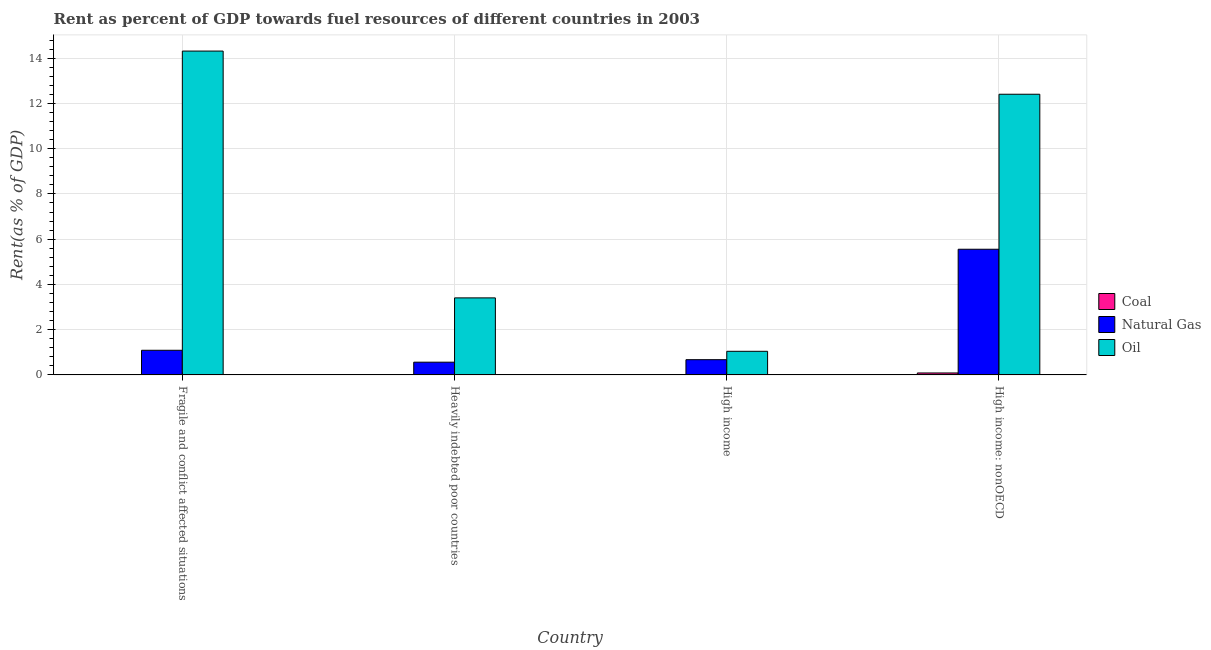How many different coloured bars are there?
Make the answer very short. 3. How many bars are there on the 2nd tick from the left?
Make the answer very short. 3. How many bars are there on the 4th tick from the right?
Make the answer very short. 3. What is the label of the 1st group of bars from the left?
Give a very brief answer. Fragile and conflict affected situations. In how many cases, is the number of bars for a given country not equal to the number of legend labels?
Provide a succinct answer. 0. What is the rent towards coal in Heavily indebted poor countries?
Give a very brief answer. 0. Across all countries, what is the maximum rent towards natural gas?
Provide a succinct answer. 5.55. Across all countries, what is the minimum rent towards oil?
Make the answer very short. 1.04. In which country was the rent towards oil maximum?
Your answer should be very brief. Fragile and conflict affected situations. In which country was the rent towards coal minimum?
Keep it short and to the point. Heavily indebted poor countries. What is the total rent towards natural gas in the graph?
Ensure brevity in your answer.  7.88. What is the difference between the rent towards natural gas in Fragile and conflict affected situations and that in High income: nonOECD?
Keep it short and to the point. -4.47. What is the difference between the rent towards natural gas in Heavily indebted poor countries and the rent towards oil in High income: nonOECD?
Offer a terse response. -11.84. What is the average rent towards coal per country?
Provide a succinct answer. 0.02. What is the difference between the rent towards natural gas and rent towards coal in High income?
Your response must be concise. 0.67. In how many countries, is the rent towards oil greater than 5.2 %?
Provide a short and direct response. 2. What is the ratio of the rent towards oil in Heavily indebted poor countries to that in High income: nonOECD?
Keep it short and to the point. 0.27. Is the rent towards natural gas in Fragile and conflict affected situations less than that in Heavily indebted poor countries?
Your answer should be very brief. No. What is the difference between the highest and the second highest rent towards natural gas?
Your answer should be compact. 4.47. What is the difference between the highest and the lowest rent towards oil?
Give a very brief answer. 13.27. What does the 3rd bar from the left in High income: nonOECD represents?
Ensure brevity in your answer.  Oil. What does the 2nd bar from the right in Heavily indebted poor countries represents?
Make the answer very short. Natural Gas. Is it the case that in every country, the sum of the rent towards coal and rent towards natural gas is greater than the rent towards oil?
Offer a terse response. No. How many bars are there?
Give a very brief answer. 12. Are all the bars in the graph horizontal?
Your answer should be very brief. No. How many countries are there in the graph?
Your answer should be compact. 4. Are the values on the major ticks of Y-axis written in scientific E-notation?
Ensure brevity in your answer.  No. Does the graph contain any zero values?
Your answer should be very brief. No. How many legend labels are there?
Your response must be concise. 3. How are the legend labels stacked?
Provide a succinct answer. Vertical. What is the title of the graph?
Give a very brief answer. Rent as percent of GDP towards fuel resources of different countries in 2003. Does "Industry" appear as one of the legend labels in the graph?
Give a very brief answer. No. What is the label or title of the Y-axis?
Your answer should be very brief. Rent(as % of GDP). What is the Rent(as % of GDP) in Coal in Fragile and conflict affected situations?
Your response must be concise. 0. What is the Rent(as % of GDP) in Natural Gas in Fragile and conflict affected situations?
Make the answer very short. 1.09. What is the Rent(as % of GDP) in Oil in Fragile and conflict affected situations?
Your response must be concise. 14.31. What is the Rent(as % of GDP) in Coal in Heavily indebted poor countries?
Your answer should be compact. 0. What is the Rent(as % of GDP) of Natural Gas in Heavily indebted poor countries?
Your response must be concise. 0.56. What is the Rent(as % of GDP) in Oil in Heavily indebted poor countries?
Your answer should be very brief. 3.4. What is the Rent(as % of GDP) of Coal in High income?
Ensure brevity in your answer.  0.01. What is the Rent(as % of GDP) in Natural Gas in High income?
Offer a terse response. 0.67. What is the Rent(as % of GDP) of Oil in High income?
Ensure brevity in your answer.  1.04. What is the Rent(as % of GDP) in Coal in High income: nonOECD?
Your answer should be very brief. 0.09. What is the Rent(as % of GDP) of Natural Gas in High income: nonOECD?
Provide a succinct answer. 5.55. What is the Rent(as % of GDP) of Oil in High income: nonOECD?
Make the answer very short. 12.4. Across all countries, what is the maximum Rent(as % of GDP) in Coal?
Your answer should be very brief. 0.09. Across all countries, what is the maximum Rent(as % of GDP) in Natural Gas?
Keep it short and to the point. 5.55. Across all countries, what is the maximum Rent(as % of GDP) of Oil?
Provide a short and direct response. 14.31. Across all countries, what is the minimum Rent(as % of GDP) of Coal?
Keep it short and to the point. 0. Across all countries, what is the minimum Rent(as % of GDP) in Natural Gas?
Your answer should be compact. 0.56. Across all countries, what is the minimum Rent(as % of GDP) in Oil?
Offer a very short reply. 1.04. What is the total Rent(as % of GDP) of Coal in the graph?
Keep it short and to the point. 0.09. What is the total Rent(as % of GDP) in Natural Gas in the graph?
Offer a very short reply. 7.88. What is the total Rent(as % of GDP) in Oil in the graph?
Provide a short and direct response. 31.17. What is the difference between the Rent(as % of GDP) in Natural Gas in Fragile and conflict affected situations and that in Heavily indebted poor countries?
Your answer should be very brief. 0.53. What is the difference between the Rent(as % of GDP) of Oil in Fragile and conflict affected situations and that in Heavily indebted poor countries?
Ensure brevity in your answer.  10.91. What is the difference between the Rent(as % of GDP) of Coal in Fragile and conflict affected situations and that in High income?
Keep it short and to the point. -0.01. What is the difference between the Rent(as % of GDP) of Natural Gas in Fragile and conflict affected situations and that in High income?
Your answer should be very brief. 0.42. What is the difference between the Rent(as % of GDP) of Oil in Fragile and conflict affected situations and that in High income?
Your answer should be very brief. 13.27. What is the difference between the Rent(as % of GDP) in Coal in Fragile and conflict affected situations and that in High income: nonOECD?
Provide a short and direct response. -0.09. What is the difference between the Rent(as % of GDP) of Natural Gas in Fragile and conflict affected situations and that in High income: nonOECD?
Give a very brief answer. -4.47. What is the difference between the Rent(as % of GDP) in Oil in Fragile and conflict affected situations and that in High income: nonOECD?
Offer a very short reply. 1.91. What is the difference between the Rent(as % of GDP) in Coal in Heavily indebted poor countries and that in High income?
Provide a short and direct response. -0.01. What is the difference between the Rent(as % of GDP) of Natural Gas in Heavily indebted poor countries and that in High income?
Your response must be concise. -0.11. What is the difference between the Rent(as % of GDP) in Oil in Heavily indebted poor countries and that in High income?
Offer a terse response. 2.36. What is the difference between the Rent(as % of GDP) in Coal in Heavily indebted poor countries and that in High income: nonOECD?
Keep it short and to the point. -0.09. What is the difference between the Rent(as % of GDP) in Natural Gas in Heavily indebted poor countries and that in High income: nonOECD?
Offer a very short reply. -4.99. What is the difference between the Rent(as % of GDP) of Oil in Heavily indebted poor countries and that in High income: nonOECD?
Your answer should be compact. -9. What is the difference between the Rent(as % of GDP) of Coal in High income and that in High income: nonOECD?
Your response must be concise. -0.08. What is the difference between the Rent(as % of GDP) in Natural Gas in High income and that in High income: nonOECD?
Give a very brief answer. -4.88. What is the difference between the Rent(as % of GDP) in Oil in High income and that in High income: nonOECD?
Offer a terse response. -11.36. What is the difference between the Rent(as % of GDP) of Coal in Fragile and conflict affected situations and the Rent(as % of GDP) of Natural Gas in Heavily indebted poor countries?
Provide a short and direct response. -0.56. What is the difference between the Rent(as % of GDP) in Coal in Fragile and conflict affected situations and the Rent(as % of GDP) in Oil in Heavily indebted poor countries?
Ensure brevity in your answer.  -3.4. What is the difference between the Rent(as % of GDP) in Natural Gas in Fragile and conflict affected situations and the Rent(as % of GDP) in Oil in Heavily indebted poor countries?
Make the answer very short. -2.32. What is the difference between the Rent(as % of GDP) in Coal in Fragile and conflict affected situations and the Rent(as % of GDP) in Natural Gas in High income?
Your answer should be compact. -0.67. What is the difference between the Rent(as % of GDP) of Coal in Fragile and conflict affected situations and the Rent(as % of GDP) of Oil in High income?
Make the answer very short. -1.04. What is the difference between the Rent(as % of GDP) of Natural Gas in Fragile and conflict affected situations and the Rent(as % of GDP) of Oil in High income?
Provide a succinct answer. 0.05. What is the difference between the Rent(as % of GDP) in Coal in Fragile and conflict affected situations and the Rent(as % of GDP) in Natural Gas in High income: nonOECD?
Provide a succinct answer. -5.55. What is the difference between the Rent(as % of GDP) of Coal in Fragile and conflict affected situations and the Rent(as % of GDP) of Oil in High income: nonOECD?
Provide a succinct answer. -12.4. What is the difference between the Rent(as % of GDP) in Natural Gas in Fragile and conflict affected situations and the Rent(as % of GDP) in Oil in High income: nonOECD?
Offer a terse response. -11.32. What is the difference between the Rent(as % of GDP) of Coal in Heavily indebted poor countries and the Rent(as % of GDP) of Natural Gas in High income?
Offer a terse response. -0.67. What is the difference between the Rent(as % of GDP) in Coal in Heavily indebted poor countries and the Rent(as % of GDP) in Oil in High income?
Provide a short and direct response. -1.04. What is the difference between the Rent(as % of GDP) of Natural Gas in Heavily indebted poor countries and the Rent(as % of GDP) of Oil in High income?
Keep it short and to the point. -0.48. What is the difference between the Rent(as % of GDP) in Coal in Heavily indebted poor countries and the Rent(as % of GDP) in Natural Gas in High income: nonOECD?
Give a very brief answer. -5.55. What is the difference between the Rent(as % of GDP) of Coal in Heavily indebted poor countries and the Rent(as % of GDP) of Oil in High income: nonOECD?
Ensure brevity in your answer.  -12.4. What is the difference between the Rent(as % of GDP) in Natural Gas in Heavily indebted poor countries and the Rent(as % of GDP) in Oil in High income: nonOECD?
Give a very brief answer. -11.84. What is the difference between the Rent(as % of GDP) in Coal in High income and the Rent(as % of GDP) in Natural Gas in High income: nonOECD?
Provide a short and direct response. -5.55. What is the difference between the Rent(as % of GDP) of Coal in High income and the Rent(as % of GDP) of Oil in High income: nonOECD?
Offer a very short reply. -12.4. What is the difference between the Rent(as % of GDP) in Natural Gas in High income and the Rent(as % of GDP) in Oil in High income: nonOECD?
Provide a short and direct response. -11.73. What is the average Rent(as % of GDP) of Coal per country?
Your response must be concise. 0.02. What is the average Rent(as % of GDP) of Natural Gas per country?
Give a very brief answer. 1.97. What is the average Rent(as % of GDP) of Oil per country?
Keep it short and to the point. 7.79. What is the difference between the Rent(as % of GDP) in Coal and Rent(as % of GDP) in Natural Gas in Fragile and conflict affected situations?
Offer a terse response. -1.09. What is the difference between the Rent(as % of GDP) of Coal and Rent(as % of GDP) of Oil in Fragile and conflict affected situations?
Offer a terse response. -14.31. What is the difference between the Rent(as % of GDP) of Natural Gas and Rent(as % of GDP) of Oil in Fragile and conflict affected situations?
Offer a terse response. -13.22. What is the difference between the Rent(as % of GDP) in Coal and Rent(as % of GDP) in Natural Gas in Heavily indebted poor countries?
Offer a terse response. -0.56. What is the difference between the Rent(as % of GDP) in Coal and Rent(as % of GDP) in Oil in Heavily indebted poor countries?
Your answer should be very brief. -3.4. What is the difference between the Rent(as % of GDP) in Natural Gas and Rent(as % of GDP) in Oil in Heavily indebted poor countries?
Give a very brief answer. -2.84. What is the difference between the Rent(as % of GDP) in Coal and Rent(as % of GDP) in Natural Gas in High income?
Your answer should be compact. -0.67. What is the difference between the Rent(as % of GDP) of Coal and Rent(as % of GDP) of Oil in High income?
Your response must be concise. -1.04. What is the difference between the Rent(as % of GDP) in Natural Gas and Rent(as % of GDP) in Oil in High income?
Offer a terse response. -0.37. What is the difference between the Rent(as % of GDP) in Coal and Rent(as % of GDP) in Natural Gas in High income: nonOECD?
Provide a short and direct response. -5.47. What is the difference between the Rent(as % of GDP) in Coal and Rent(as % of GDP) in Oil in High income: nonOECD?
Keep it short and to the point. -12.32. What is the difference between the Rent(as % of GDP) of Natural Gas and Rent(as % of GDP) of Oil in High income: nonOECD?
Offer a very short reply. -6.85. What is the ratio of the Rent(as % of GDP) of Coal in Fragile and conflict affected situations to that in Heavily indebted poor countries?
Offer a terse response. 1.05. What is the ratio of the Rent(as % of GDP) of Natural Gas in Fragile and conflict affected situations to that in Heavily indebted poor countries?
Offer a very short reply. 1.94. What is the ratio of the Rent(as % of GDP) of Oil in Fragile and conflict affected situations to that in Heavily indebted poor countries?
Provide a short and direct response. 4.2. What is the ratio of the Rent(as % of GDP) of Coal in Fragile and conflict affected situations to that in High income?
Your answer should be very brief. 0.02. What is the ratio of the Rent(as % of GDP) in Natural Gas in Fragile and conflict affected situations to that in High income?
Offer a very short reply. 1.62. What is the ratio of the Rent(as % of GDP) of Oil in Fragile and conflict affected situations to that in High income?
Provide a short and direct response. 13.72. What is the ratio of the Rent(as % of GDP) in Coal in Fragile and conflict affected situations to that in High income: nonOECD?
Keep it short and to the point. 0. What is the ratio of the Rent(as % of GDP) of Natural Gas in Fragile and conflict affected situations to that in High income: nonOECD?
Your response must be concise. 0.2. What is the ratio of the Rent(as % of GDP) of Oil in Fragile and conflict affected situations to that in High income: nonOECD?
Make the answer very short. 1.15. What is the ratio of the Rent(as % of GDP) of Coal in Heavily indebted poor countries to that in High income?
Offer a very short reply. 0.02. What is the ratio of the Rent(as % of GDP) in Natural Gas in Heavily indebted poor countries to that in High income?
Your response must be concise. 0.84. What is the ratio of the Rent(as % of GDP) in Oil in Heavily indebted poor countries to that in High income?
Keep it short and to the point. 3.26. What is the ratio of the Rent(as % of GDP) in Coal in Heavily indebted poor countries to that in High income: nonOECD?
Your answer should be compact. 0. What is the ratio of the Rent(as % of GDP) of Natural Gas in Heavily indebted poor countries to that in High income: nonOECD?
Offer a very short reply. 0.1. What is the ratio of the Rent(as % of GDP) in Oil in Heavily indebted poor countries to that in High income: nonOECD?
Provide a short and direct response. 0.27. What is the ratio of the Rent(as % of GDP) of Coal in High income to that in High income: nonOECD?
Make the answer very short. 0.07. What is the ratio of the Rent(as % of GDP) of Natural Gas in High income to that in High income: nonOECD?
Give a very brief answer. 0.12. What is the ratio of the Rent(as % of GDP) of Oil in High income to that in High income: nonOECD?
Offer a terse response. 0.08. What is the difference between the highest and the second highest Rent(as % of GDP) in Coal?
Provide a succinct answer. 0.08. What is the difference between the highest and the second highest Rent(as % of GDP) in Natural Gas?
Offer a terse response. 4.47. What is the difference between the highest and the second highest Rent(as % of GDP) in Oil?
Offer a terse response. 1.91. What is the difference between the highest and the lowest Rent(as % of GDP) in Coal?
Offer a terse response. 0.09. What is the difference between the highest and the lowest Rent(as % of GDP) in Natural Gas?
Offer a terse response. 4.99. What is the difference between the highest and the lowest Rent(as % of GDP) in Oil?
Your answer should be compact. 13.27. 